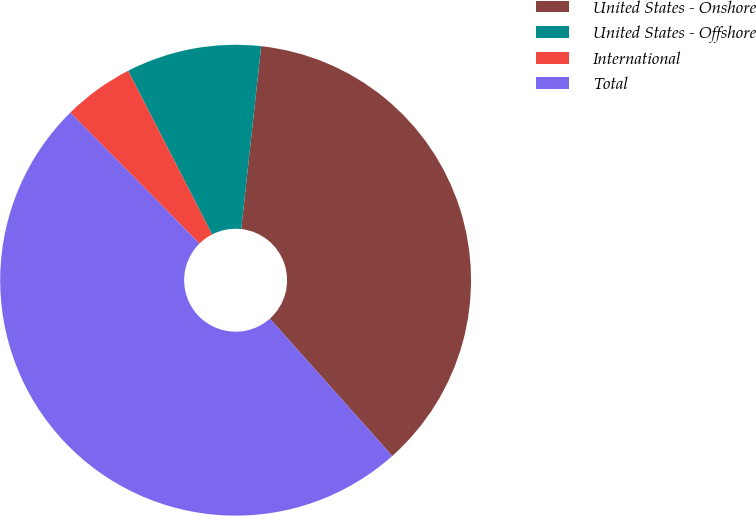Convert chart to OTSL. <chart><loc_0><loc_0><loc_500><loc_500><pie_chart><fcel>United States - Onshore<fcel>United States - Offshore<fcel>International<fcel>Total<nl><fcel>36.68%<fcel>9.28%<fcel>4.84%<fcel>49.2%<nl></chart> 